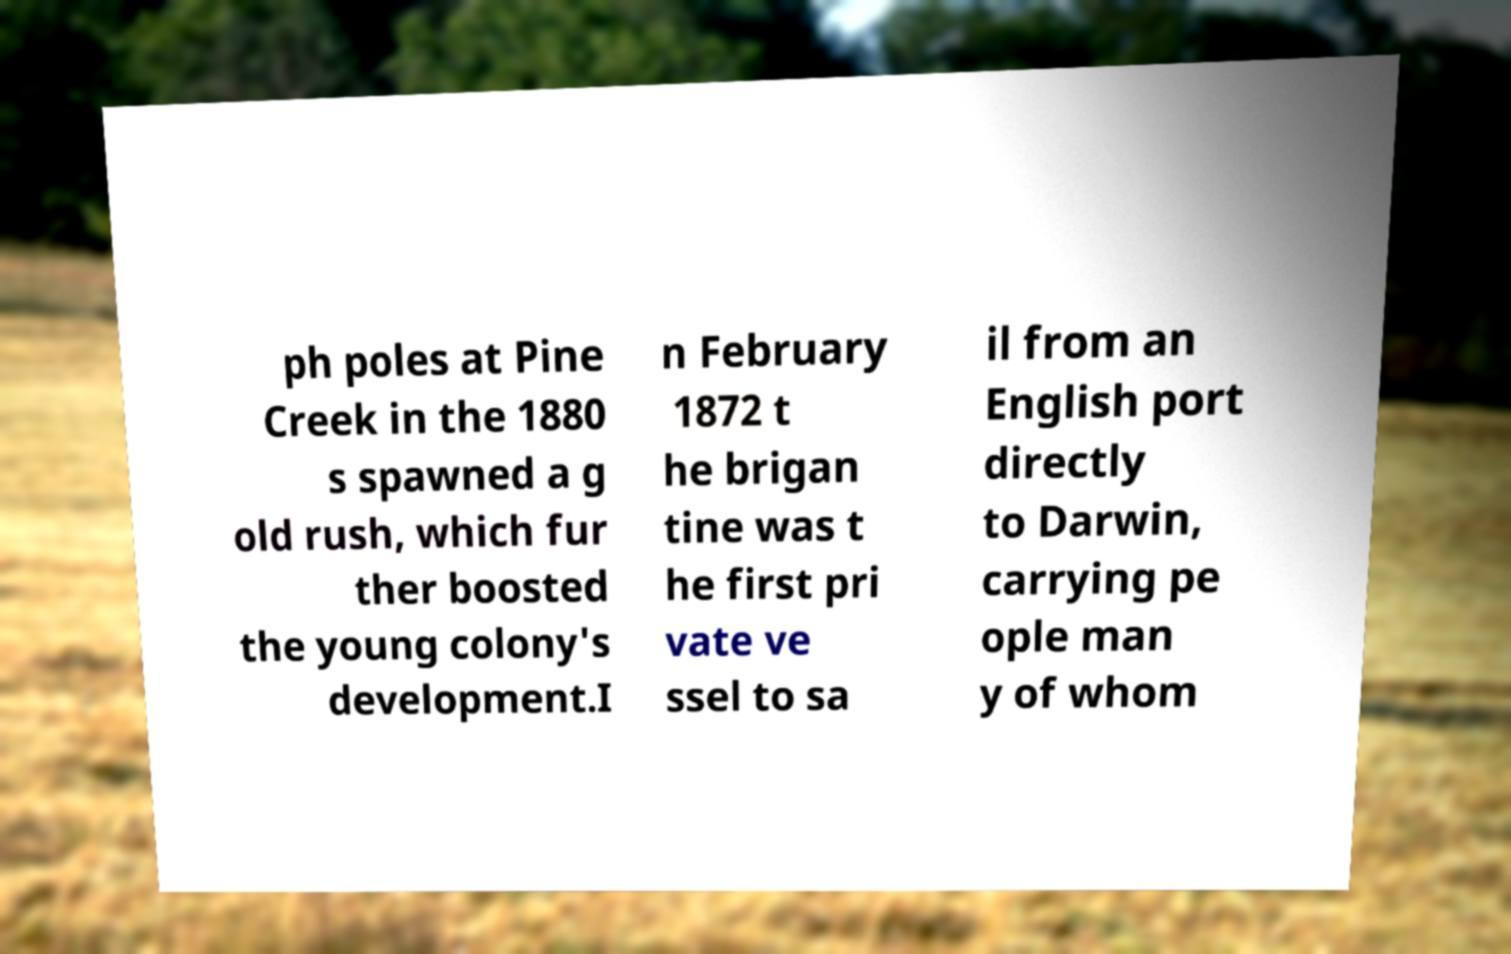Please read and relay the text visible in this image. What does it say? ph poles at Pine Creek in the 1880 s spawned a g old rush, which fur ther boosted the young colony's development.I n February 1872 t he brigan tine was t he first pri vate ve ssel to sa il from an English port directly to Darwin, carrying pe ople man y of whom 